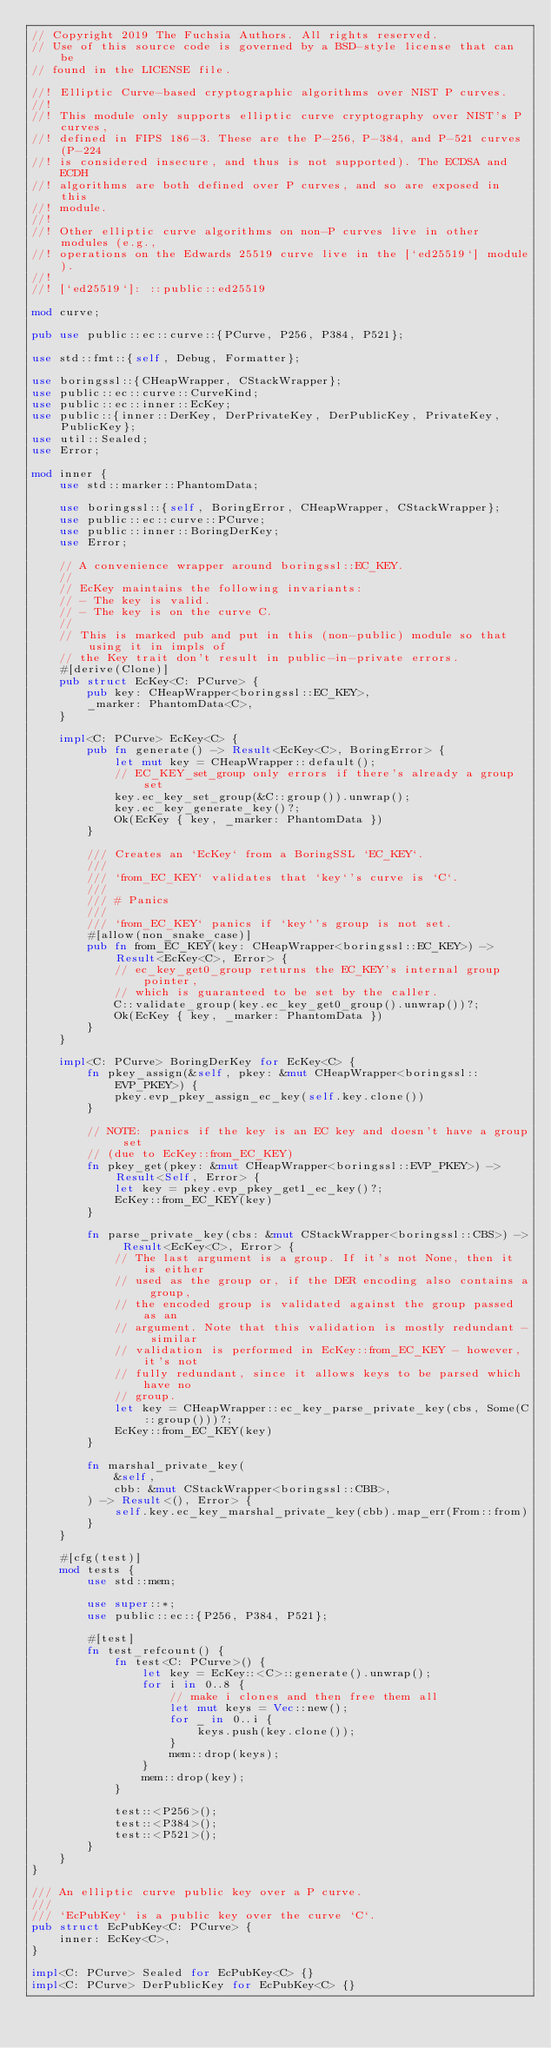<code> <loc_0><loc_0><loc_500><loc_500><_Rust_>// Copyright 2019 The Fuchsia Authors. All rights reserved.
// Use of this source code is governed by a BSD-style license that can be
// found in the LICENSE file.

//! Elliptic Curve-based cryptographic algorithms over NIST P curves.
//!
//! This module only supports elliptic curve cryptography over NIST's P curves,
//! defined in FIPS 186-3. These are the P-256, P-384, and P-521 curves (P-224
//! is considered insecure, and thus is not supported). The ECDSA and ECDH
//! algorithms are both defined over P curves, and so are exposed in this
//! module.
//!
//! Other elliptic curve algorithms on non-P curves live in other modules (e.g.,
//! operations on the Edwards 25519 curve live in the [`ed25519`] module).
//!
//! [`ed25519`]: ::public::ed25519

mod curve;

pub use public::ec::curve::{PCurve, P256, P384, P521};

use std::fmt::{self, Debug, Formatter};

use boringssl::{CHeapWrapper, CStackWrapper};
use public::ec::curve::CurveKind;
use public::ec::inner::EcKey;
use public::{inner::DerKey, DerPrivateKey, DerPublicKey, PrivateKey, PublicKey};
use util::Sealed;
use Error;

mod inner {
    use std::marker::PhantomData;

    use boringssl::{self, BoringError, CHeapWrapper, CStackWrapper};
    use public::ec::curve::PCurve;
    use public::inner::BoringDerKey;
    use Error;

    // A convenience wrapper around boringssl::EC_KEY.
    //
    // EcKey maintains the following invariants:
    // - The key is valid.
    // - The key is on the curve C.
    //
    // This is marked pub and put in this (non-public) module so that using it in impls of
    // the Key trait don't result in public-in-private errors.
    #[derive(Clone)]
    pub struct EcKey<C: PCurve> {
        pub key: CHeapWrapper<boringssl::EC_KEY>,
        _marker: PhantomData<C>,
    }

    impl<C: PCurve> EcKey<C> {
        pub fn generate() -> Result<EcKey<C>, BoringError> {
            let mut key = CHeapWrapper::default();
            // EC_KEY_set_group only errors if there's already a group set
            key.ec_key_set_group(&C::group()).unwrap();
            key.ec_key_generate_key()?;
            Ok(EcKey { key, _marker: PhantomData })
        }

        /// Creates an `EcKey` from a BoringSSL `EC_KEY`.
        ///
        /// `from_EC_KEY` validates that `key`'s curve is `C`.
        ///
        /// # Panics
        ///
        /// `from_EC_KEY` panics if `key`'s group is not set.
        #[allow(non_snake_case)]
        pub fn from_EC_KEY(key: CHeapWrapper<boringssl::EC_KEY>) -> Result<EcKey<C>, Error> {
            // ec_key_get0_group returns the EC_KEY's internal group pointer,
            // which is guaranteed to be set by the caller.
            C::validate_group(key.ec_key_get0_group().unwrap())?;
            Ok(EcKey { key, _marker: PhantomData })
        }
    }

    impl<C: PCurve> BoringDerKey for EcKey<C> {
        fn pkey_assign(&self, pkey: &mut CHeapWrapper<boringssl::EVP_PKEY>) {
            pkey.evp_pkey_assign_ec_key(self.key.clone())
        }

        // NOTE: panics if the key is an EC key and doesn't have a group set
        // (due to EcKey::from_EC_KEY)
        fn pkey_get(pkey: &mut CHeapWrapper<boringssl::EVP_PKEY>) -> Result<Self, Error> {
            let key = pkey.evp_pkey_get1_ec_key()?;
            EcKey::from_EC_KEY(key)
        }

        fn parse_private_key(cbs: &mut CStackWrapper<boringssl::CBS>) -> Result<EcKey<C>, Error> {
            // The last argument is a group. If it's not None, then it is either
            // used as the group or, if the DER encoding also contains a group,
            // the encoded group is validated against the group passed as an
            // argument. Note that this validation is mostly redundant - similar
            // validation is performed in EcKey::from_EC_KEY - however, it's not
            // fully redundant, since it allows keys to be parsed which have no
            // group.
            let key = CHeapWrapper::ec_key_parse_private_key(cbs, Some(C::group()))?;
            EcKey::from_EC_KEY(key)
        }

        fn marshal_private_key(
            &self,
            cbb: &mut CStackWrapper<boringssl::CBB>,
        ) -> Result<(), Error> {
            self.key.ec_key_marshal_private_key(cbb).map_err(From::from)
        }
    }

    #[cfg(test)]
    mod tests {
        use std::mem;

        use super::*;
        use public::ec::{P256, P384, P521};

        #[test]
        fn test_refcount() {
            fn test<C: PCurve>() {
                let key = EcKey::<C>::generate().unwrap();
                for i in 0..8 {
                    // make i clones and then free them all
                    let mut keys = Vec::new();
                    for _ in 0..i {
                        keys.push(key.clone());
                    }
                    mem::drop(keys);
                }
                mem::drop(key);
            }

            test::<P256>();
            test::<P384>();
            test::<P521>();
        }
    }
}

/// An elliptic curve public key over a P curve.
///
/// `EcPubKey` is a public key over the curve `C`.
pub struct EcPubKey<C: PCurve> {
    inner: EcKey<C>,
}

impl<C: PCurve> Sealed for EcPubKey<C> {}
impl<C: PCurve> DerPublicKey for EcPubKey<C> {}
</code> 